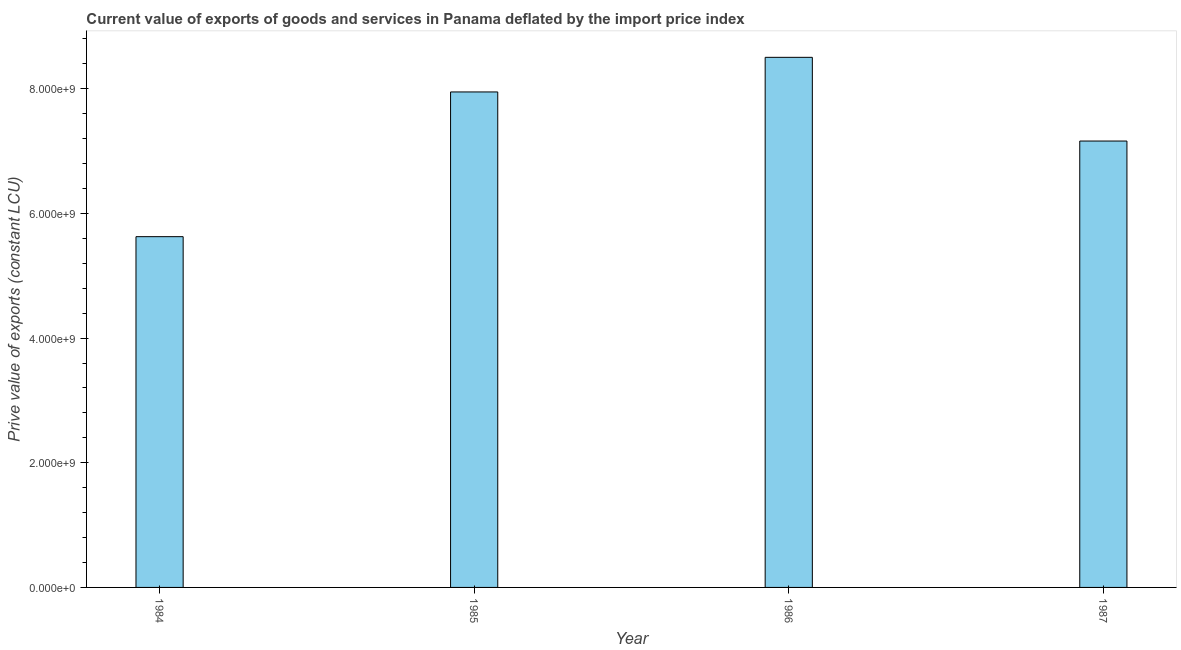Does the graph contain any zero values?
Your answer should be compact. No. Does the graph contain grids?
Offer a very short reply. No. What is the title of the graph?
Provide a short and direct response. Current value of exports of goods and services in Panama deflated by the import price index. What is the label or title of the X-axis?
Your answer should be compact. Year. What is the label or title of the Y-axis?
Your response must be concise. Prive value of exports (constant LCU). What is the price value of exports in 1987?
Your response must be concise. 7.16e+09. Across all years, what is the maximum price value of exports?
Offer a terse response. 8.50e+09. Across all years, what is the minimum price value of exports?
Provide a short and direct response. 5.63e+09. What is the sum of the price value of exports?
Your answer should be compact. 2.92e+1. What is the difference between the price value of exports in 1984 and 1986?
Ensure brevity in your answer.  -2.88e+09. What is the average price value of exports per year?
Your response must be concise. 7.31e+09. What is the median price value of exports?
Give a very brief answer. 7.56e+09. What is the ratio of the price value of exports in 1984 to that in 1985?
Your answer should be very brief. 0.71. Is the price value of exports in 1984 less than that in 1986?
Give a very brief answer. Yes. Is the difference between the price value of exports in 1985 and 1986 greater than the difference between any two years?
Offer a very short reply. No. What is the difference between the highest and the second highest price value of exports?
Your answer should be very brief. 5.55e+08. What is the difference between the highest and the lowest price value of exports?
Offer a terse response. 2.88e+09. How many bars are there?
Offer a very short reply. 4. How many years are there in the graph?
Your answer should be very brief. 4. What is the difference between two consecutive major ticks on the Y-axis?
Your answer should be compact. 2.00e+09. What is the Prive value of exports (constant LCU) of 1984?
Give a very brief answer. 5.63e+09. What is the Prive value of exports (constant LCU) of 1985?
Ensure brevity in your answer.  7.95e+09. What is the Prive value of exports (constant LCU) of 1986?
Your answer should be compact. 8.50e+09. What is the Prive value of exports (constant LCU) in 1987?
Offer a very short reply. 7.16e+09. What is the difference between the Prive value of exports (constant LCU) in 1984 and 1985?
Provide a succinct answer. -2.32e+09. What is the difference between the Prive value of exports (constant LCU) in 1984 and 1986?
Your answer should be compact. -2.88e+09. What is the difference between the Prive value of exports (constant LCU) in 1984 and 1987?
Give a very brief answer. -1.53e+09. What is the difference between the Prive value of exports (constant LCU) in 1985 and 1986?
Keep it short and to the point. -5.55e+08. What is the difference between the Prive value of exports (constant LCU) in 1985 and 1987?
Make the answer very short. 7.88e+08. What is the difference between the Prive value of exports (constant LCU) in 1986 and 1987?
Keep it short and to the point. 1.34e+09. What is the ratio of the Prive value of exports (constant LCU) in 1984 to that in 1985?
Your response must be concise. 0.71. What is the ratio of the Prive value of exports (constant LCU) in 1984 to that in 1986?
Provide a short and direct response. 0.66. What is the ratio of the Prive value of exports (constant LCU) in 1984 to that in 1987?
Your answer should be compact. 0.79. What is the ratio of the Prive value of exports (constant LCU) in 1985 to that in 1986?
Your answer should be compact. 0.94. What is the ratio of the Prive value of exports (constant LCU) in 1985 to that in 1987?
Make the answer very short. 1.11. What is the ratio of the Prive value of exports (constant LCU) in 1986 to that in 1987?
Keep it short and to the point. 1.19. 